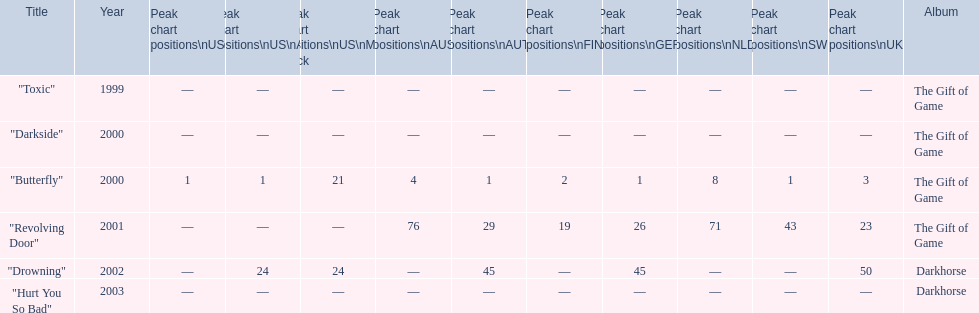How many more chart positions did "revolving door" reach in the uk compared to "drowning"? 27. 